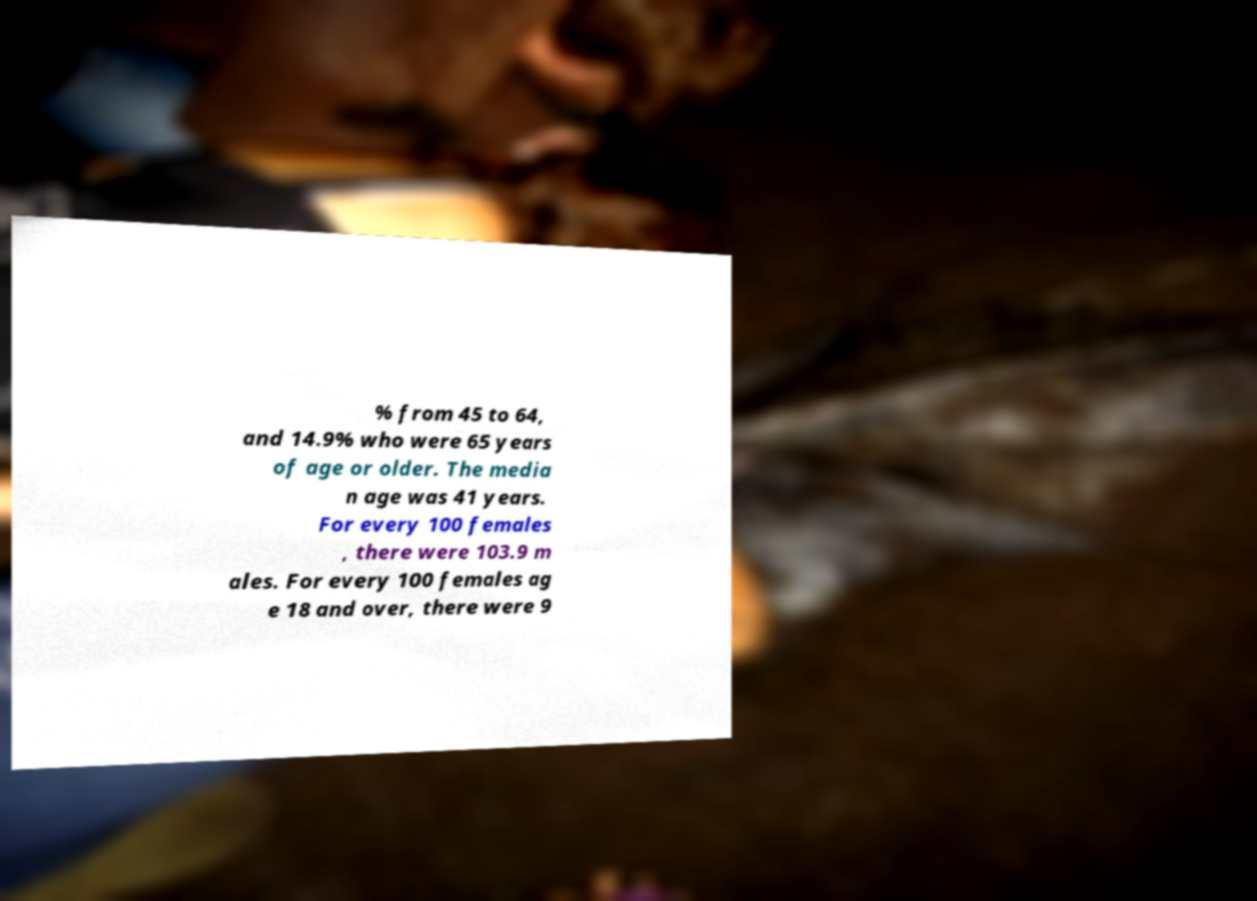I need the written content from this picture converted into text. Can you do that? % from 45 to 64, and 14.9% who were 65 years of age or older. The media n age was 41 years. For every 100 females , there were 103.9 m ales. For every 100 females ag e 18 and over, there were 9 